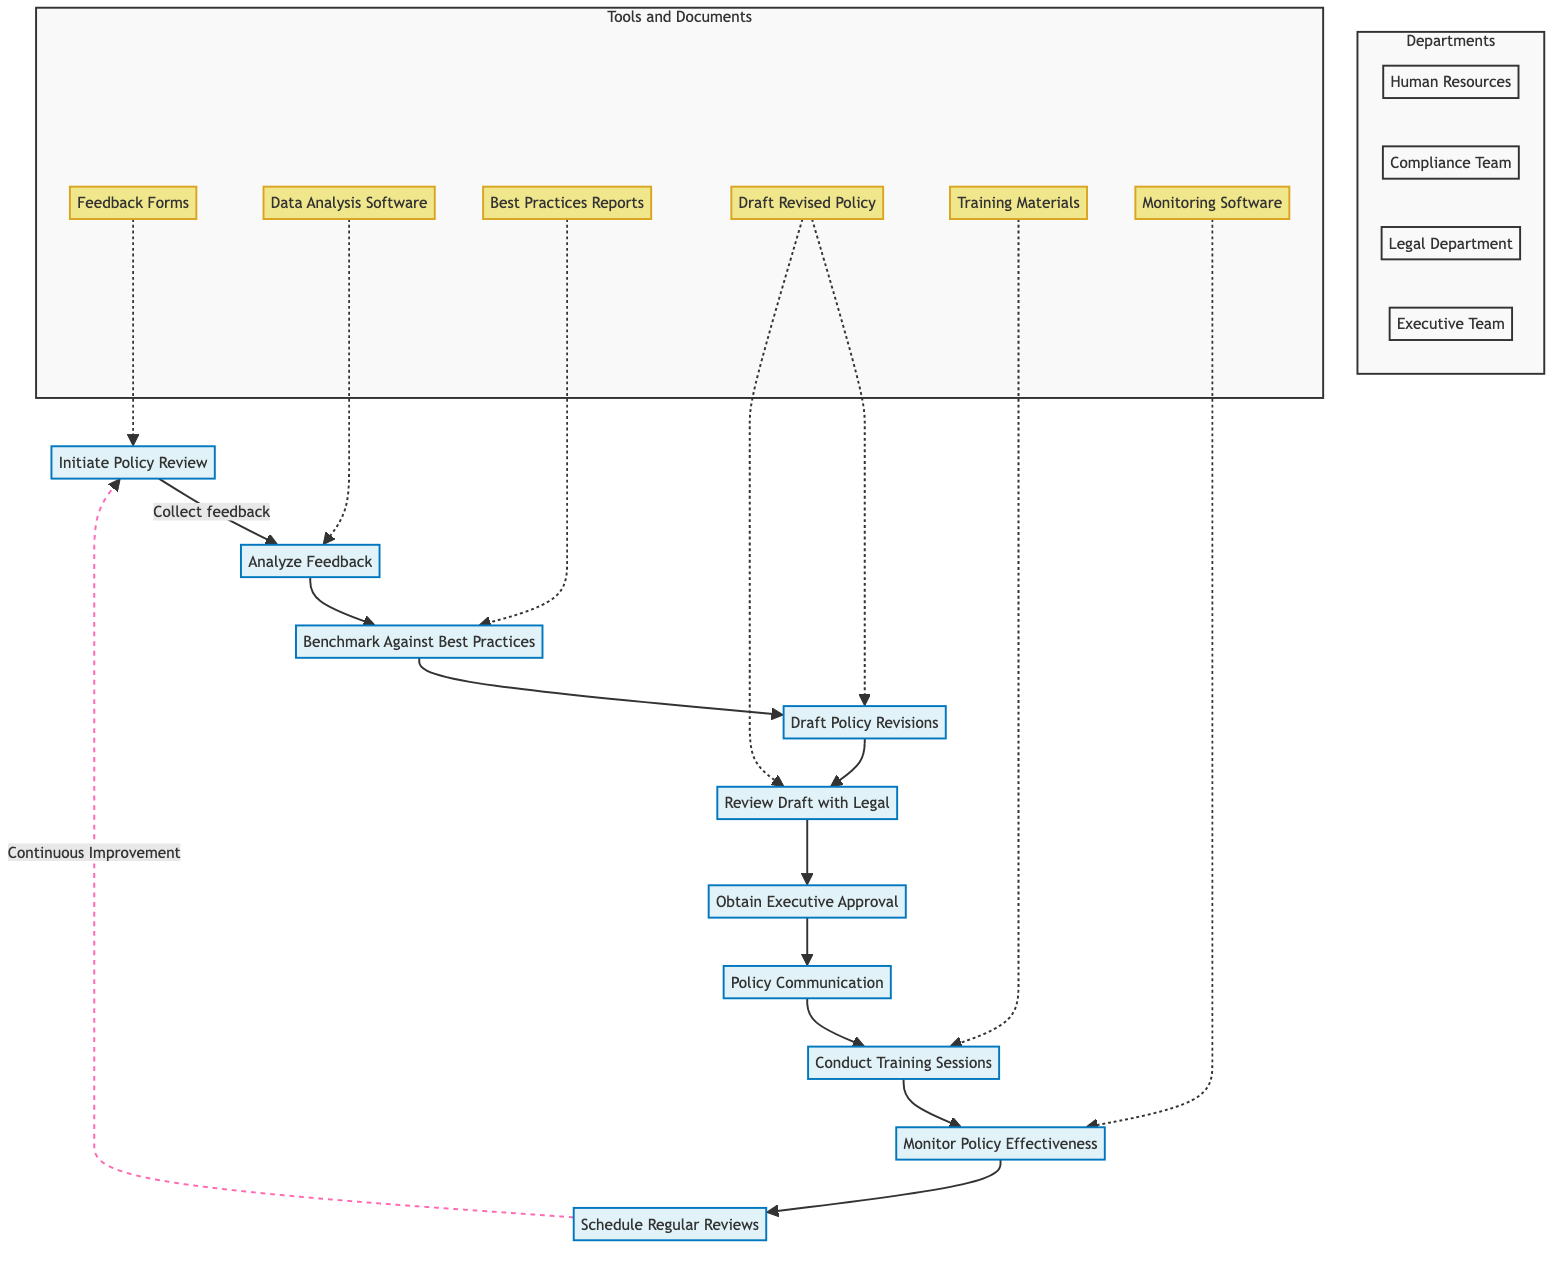What is the first step in the policy review process? The first step is "Initiate Policy Review," as indicated by the starting node in the flowchart. This phase involves collecting feedback from employees and stakeholders.
Answer: Initiate Policy Review Which department is responsible for analyzing feedback? The "Analyze Feedback" step is handled by the "Compliance Team." This can be traced from the flowchart’s connections, showing responsibility assignment.
Answer: Compliance Team How many total steps are included in this flowchart? The flowchart outlines ten distinct steps, from initiating the review to scheduling regular reviews. Counting the nodes gives the total number.
Answer: Ten What documents are needed for "Draft Policy Revisions"? According to the diagram, the required document for "Draft Policy Revisions" is "Draft Revised Policy Document." This is specified under the respective step in the flowchart.
Answer: Draft Revised Policy Document What action follows obtaining executive approval? After "Obtain Executive Approval," the subsequent action as per the diagram is "Policy Communication." This is determined by the directional connections between the nodes.
Answer: Policy Communication Which tool is used during the "Monitor Policy Effectiveness" step? The tool specified for "Monitor Policy Effectiveness" is "Monitoring Software," referenced under that particular step in the diagram.
Answer: Monitoring Software How does the policy improvement process loop back for continuous improvement? The flowchart indicates a dotted line from "Schedule Regular Reviews" back to "Initiate Policy Review," illustrating the cyclic nature of the policy review process for ongoing enhancement.
Answer: Continuous Improvement What is the last action taken after conducting training sessions? The final action after "Conduct Training Sessions" in the diagram is "Monitor Policy Effectiveness," establishing a sequence in the whistleblower policy review process.
Answer: Monitor Policy Effectiveness What does "Benchmark Against Best Practices" entail? This step involves comparing the existing whistleblower policy with industry best practices and regulatory requirements. It’s a critical evaluative action in the policy review process.
Answer: Compare with best practices Which department handles communication of the revised policy? The "Human Resources" department is responsible for "Policy Communication," as inferred from the departmental assignments visible in the flowchart.
Answer: Human Resources 